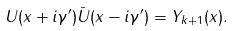Convert formula to latex. <formula><loc_0><loc_0><loc_500><loc_500>U ( x + i \gamma ^ { \prime } ) \bar { U } ( x - i \gamma ^ { \prime } ) = Y _ { k + 1 } ( x ) .</formula> 